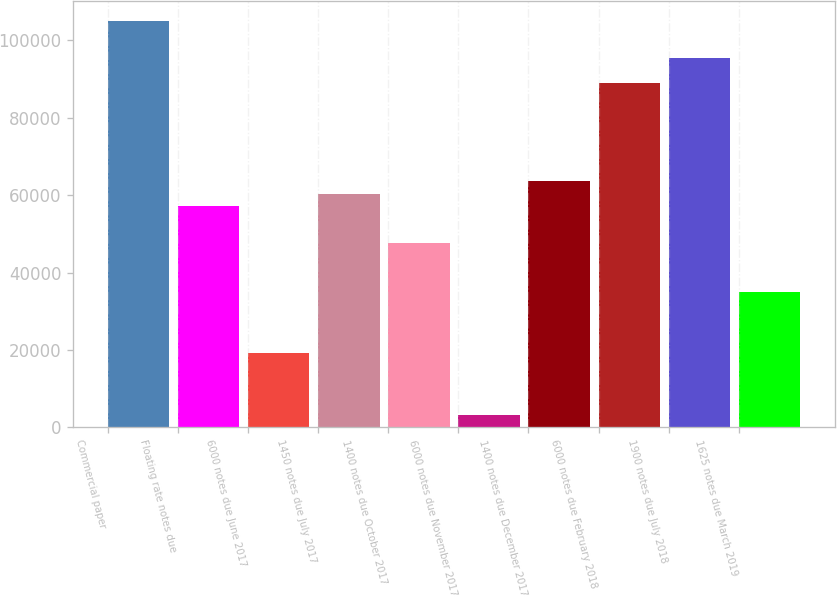Convert chart to OTSL. <chart><loc_0><loc_0><loc_500><loc_500><bar_chart><fcel>Commercial paper<fcel>Floating rate notes due<fcel>6000 notes due June 2017<fcel>1450 notes due July 2017<fcel>1400 notes due October 2017<fcel>6000 notes due November 2017<fcel>1400 notes due December 2017<fcel>6000 notes due February 2018<fcel>1900 notes due July 2018<fcel>1625 notes due March 2019<nl><fcel>104920<fcel>57233.8<fcel>19084.6<fcel>60412.9<fcel>47696.5<fcel>3189.1<fcel>63592<fcel>89024.8<fcel>95383<fcel>34980.1<nl></chart> 